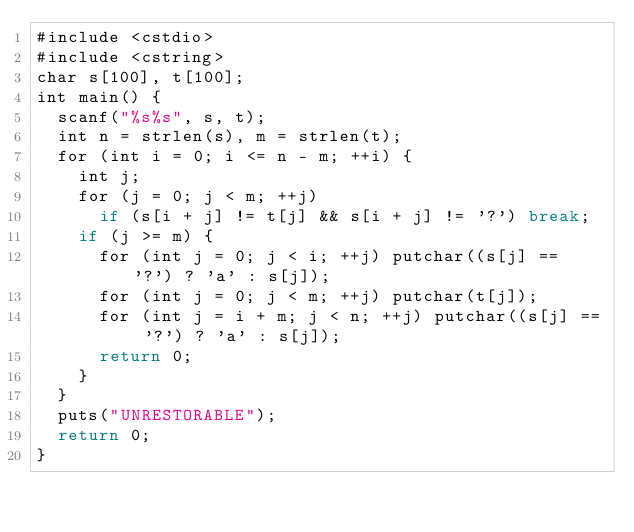<code> <loc_0><loc_0><loc_500><loc_500><_Haskell_>#include <cstdio>
#include <cstring>
char s[100], t[100];
int main() {
  scanf("%s%s", s, t);
  int n = strlen(s), m = strlen(t);
  for (int i = 0; i <= n - m; ++i) {
    int j;
    for (j = 0; j < m; ++j)
      if (s[i + j] != t[j] && s[i + j] != '?') break;
    if (j >= m) {
      for (int j = 0; j < i; ++j) putchar((s[j] == '?') ? 'a' : s[j]);
      for (int j = 0; j < m; ++j) putchar(t[j]);
      for (int j = i + m; j < n; ++j) putchar((s[j] == '?') ? 'a' : s[j]);
      return 0;
    }
  }
  puts("UNRESTORABLE");
  return 0;
}</code> 